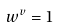<formula> <loc_0><loc_0><loc_500><loc_500>w ^ { v } = 1</formula> 